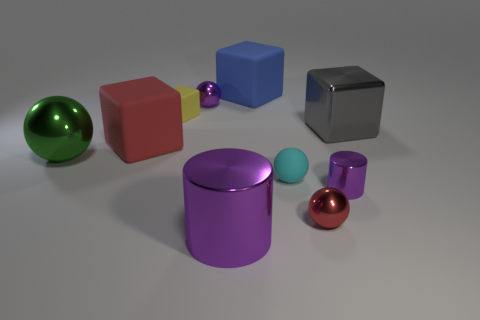Is the number of tiny cyan objects behind the yellow rubber object the same as the number of small yellow matte objects that are behind the red matte cube?
Your response must be concise. No. What number of metal objects are the same color as the large metallic cylinder?
Provide a short and direct response. 2. There is a tiny ball that is the same color as the small metallic cylinder; what is its material?
Offer a very short reply. Metal. How many rubber objects are either large red blocks or small cylinders?
Keep it short and to the point. 1. There is a red thing to the right of the large red object; does it have the same shape as the purple thing on the right side of the blue rubber object?
Keep it short and to the point. No. There is a metallic cube; what number of cyan things are to the left of it?
Your response must be concise. 1. Are there any blue things that have the same material as the red cube?
Ensure brevity in your answer.  Yes. There is a purple ball that is the same size as the yellow block; what is its material?
Offer a terse response. Metal. Does the tiny yellow block have the same material as the blue object?
Make the answer very short. Yes. What number of objects are either small objects or big objects?
Offer a very short reply. 10. 